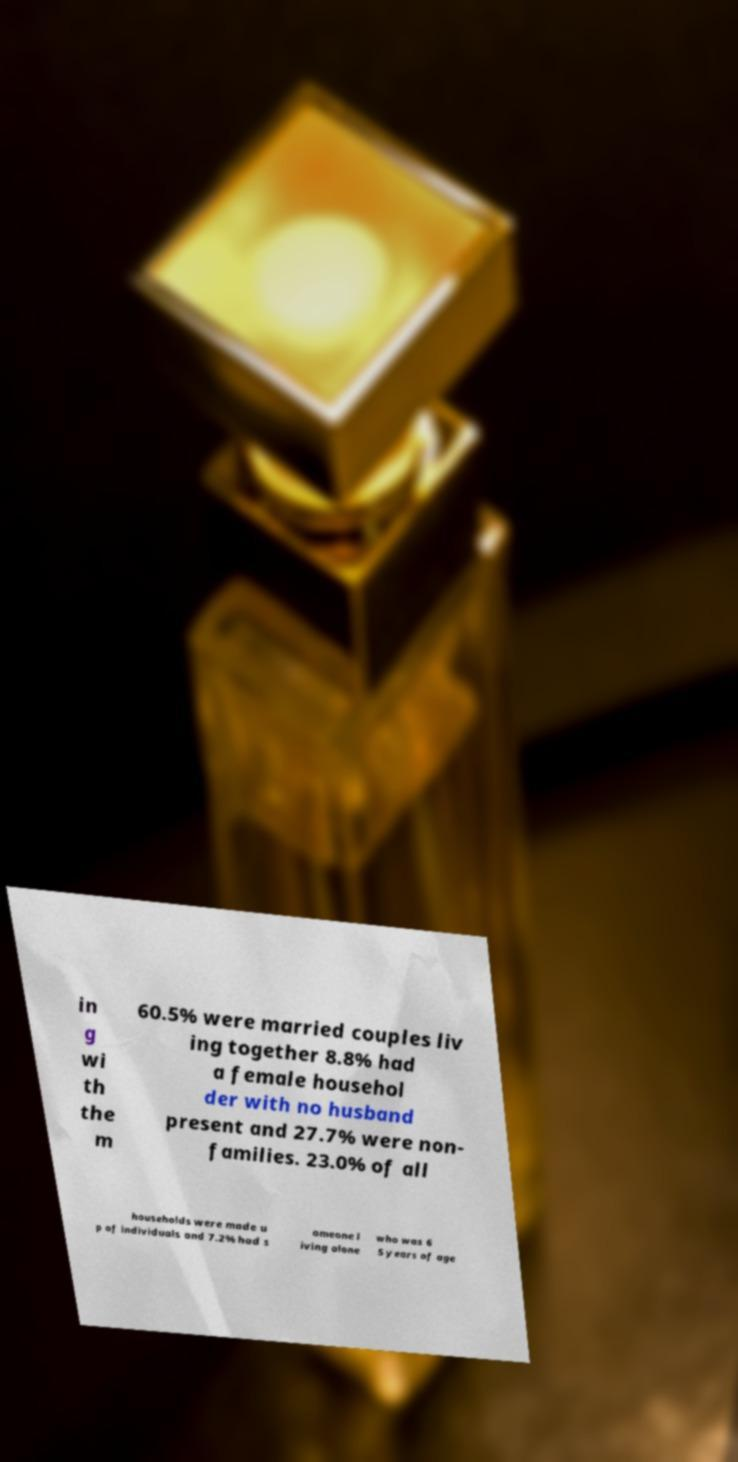Can you accurately transcribe the text from the provided image for me? in g wi th the m 60.5% were married couples liv ing together 8.8% had a female househol der with no husband present and 27.7% were non- families. 23.0% of all households were made u p of individuals and 7.2% had s omeone l iving alone who was 6 5 years of age 